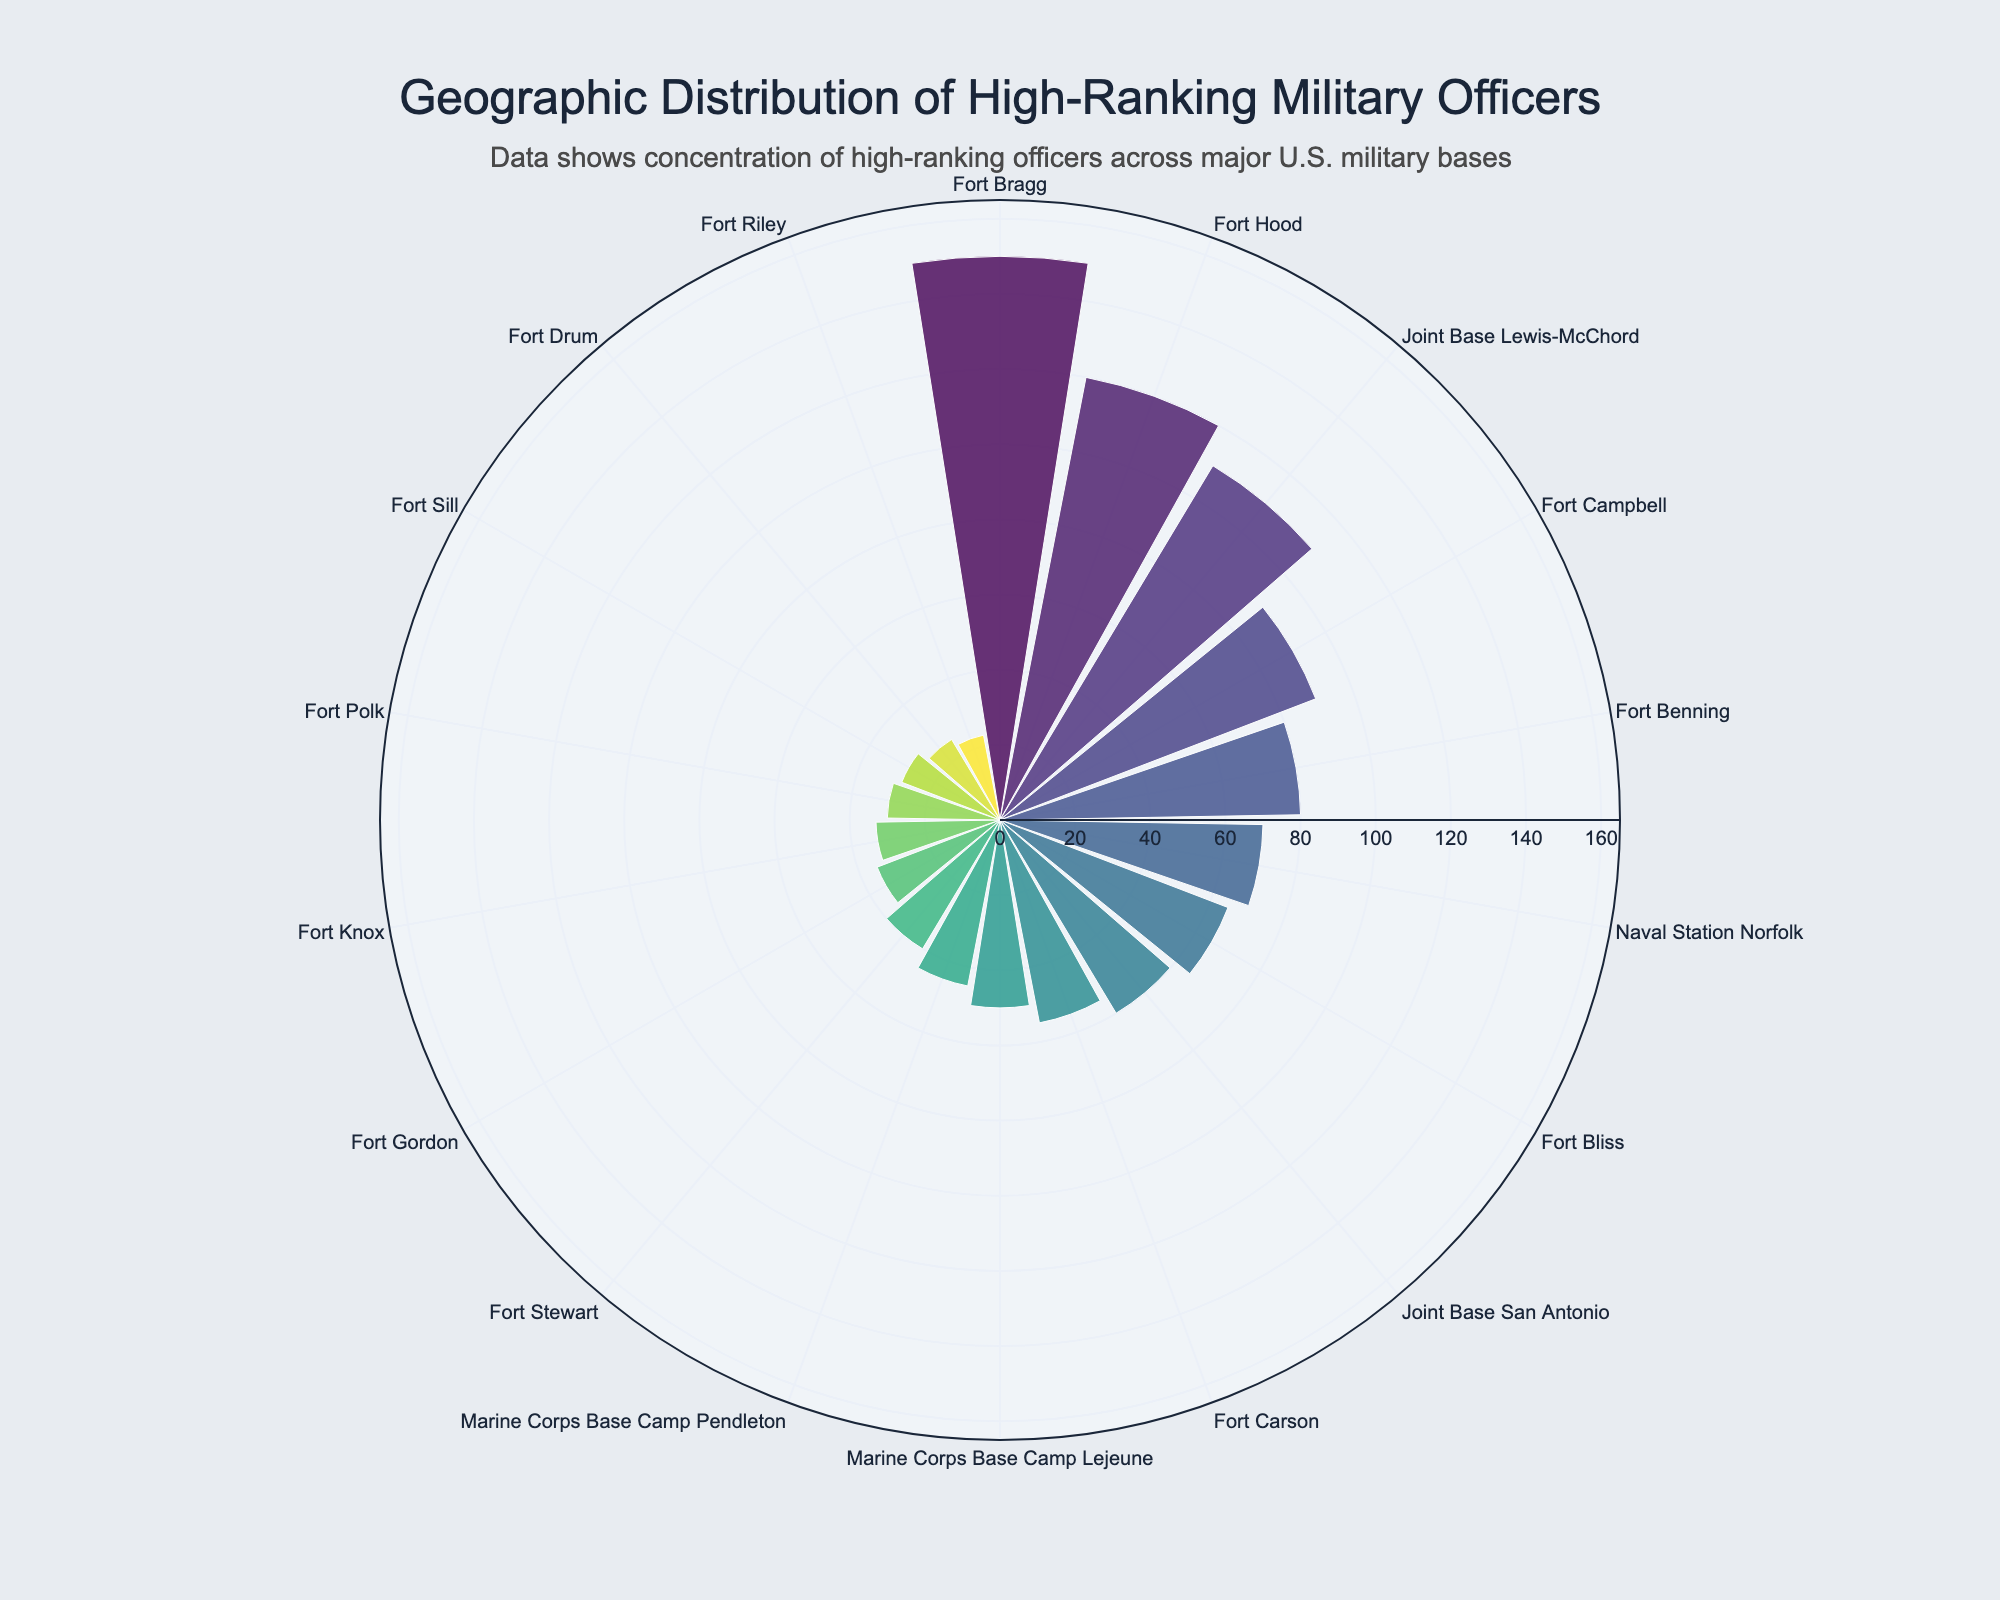What is the title of the chart? The title of the chart is typically displayed at the top of the figure and provides an overview of the content. Here, you can see the title clearly at the top.
Answer: Geographic Distribution of High-Ranking Military Officers How many bases are there in total? Count the number of unique bases listed along the angular axis of the rose chart. Each base corresponds to one data point on the chart.
Answer: 18 Which base has the highest number of high-ranking officers? Look for the base with the longest bar (highest value) in the rose chart. The hovertext or labels can also help in identifying this.
Answer: Fort Bragg How many high-ranking officers are there in Texas across all bases? Identify the bases in Texas (Fort Hood, Fort Bliss, Joint Base San Antonio) and sum their number of high-ranking officers: 120 + 65 + 60.
Answer: 245 Which state has the most number of high-ranking officers overall? Calculate the total number of high-ranking officers for each state by summing the values for bases located in the same state. Compare the sums to find the maximum.
Answer: Texas What is the difference in the number of high-ranking officers between Fort Bragg and Fort Hood? Find the values for Fort Bragg and Fort Hood, then subtract the smaller value from the larger one: 150 - 120.
Answer: 30 What color scale is used in the chart? The chart uses a color scale to represent different values. Observe the colors used for the bars and refer to the legend or color description if available.
Answer: Viridis Which base is represented by the second longest bar in the chart? Identify the second longest bar in the rose chart and check the corresponding label or hovertext for the base name.
Answer: Fort Hood How many high-ranking officers are there in total across all bases in North Carolina? Sum the number of high-ranking officers in North Carolina by adding the values for Fort Bragg and Marine Corps Base Camp Lejeune: 150 + 50.
Answer: 200 What is the average number of high-ranking officers per base in Georgia? Identify the bases in Georgia (Fort Benning, Fort Stewart, Fort Gordon) and their officers: 80, 40, 35. Sum these values and divide by the number of bases. (80 + 40 + 35) / 3.
Answer: 51.67 